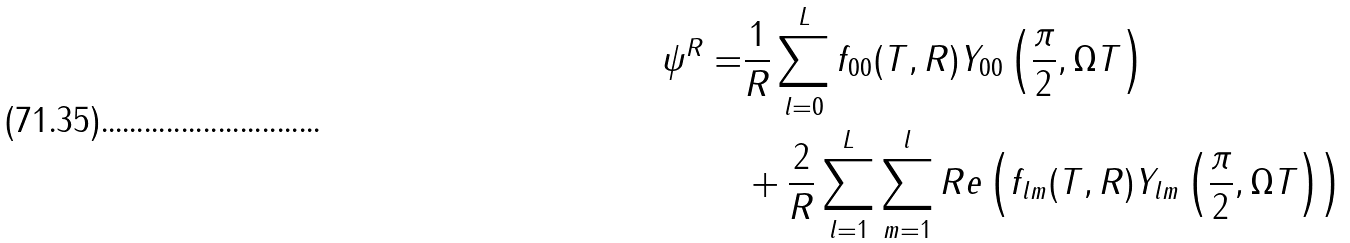<formula> <loc_0><loc_0><loc_500><loc_500>\psi ^ { R } = & \frac { 1 } { R } \sum _ { l = 0 } ^ { L } f _ { 0 0 } ( T , R ) Y _ { 0 0 } \left ( \frac { \pi } { 2 } , \Omega T \right ) \\ & + \frac { 2 } { R } \sum _ { l = 1 } ^ { L } \sum _ { m = 1 } ^ { l } R e \left ( f _ { l m } ( T , R ) Y _ { l m } \left ( \frac { \pi } { 2 } , \Omega T \right ) \right )</formula> 